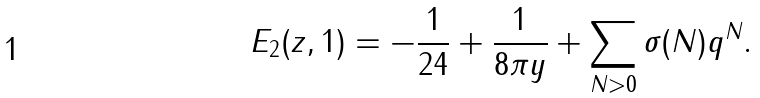<formula> <loc_0><loc_0><loc_500><loc_500>E _ { 2 } ( z , 1 ) = - \frac { 1 } { 2 4 } + \frac { 1 } { 8 \pi y } + \sum _ { N > 0 } \sigma ( N ) q ^ { N } .</formula> 